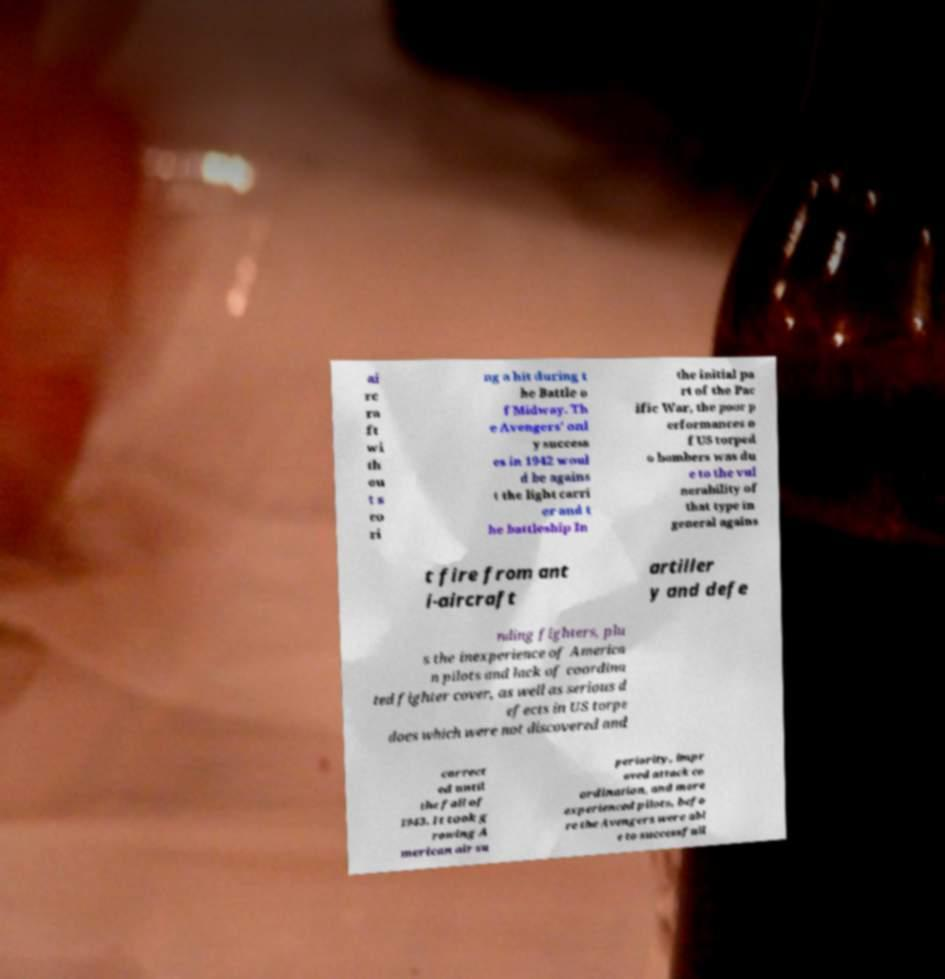Please read and relay the text visible in this image. What does it say? ai rc ra ft wi th ou t s co ri ng a hit during t he Battle o f Midway. Th e Avengers' onl y success es in 1942 woul d be agains t the light carri er and t he battleship In the initial pa rt of the Pac ific War, the poor p erformances o f US torped o bombers was du e to the vul nerability of that type in general agains t fire from ant i-aircraft artiller y and defe nding fighters, plu s the inexperience of America n pilots and lack of coordina ted fighter cover, as well as serious d efects in US torpe does which were not discovered and correct ed until the fall of 1943. It took g rowing A merican air su periority, impr oved attack co ordination, and more experienced pilots, befo re the Avengers were abl e to successfull 